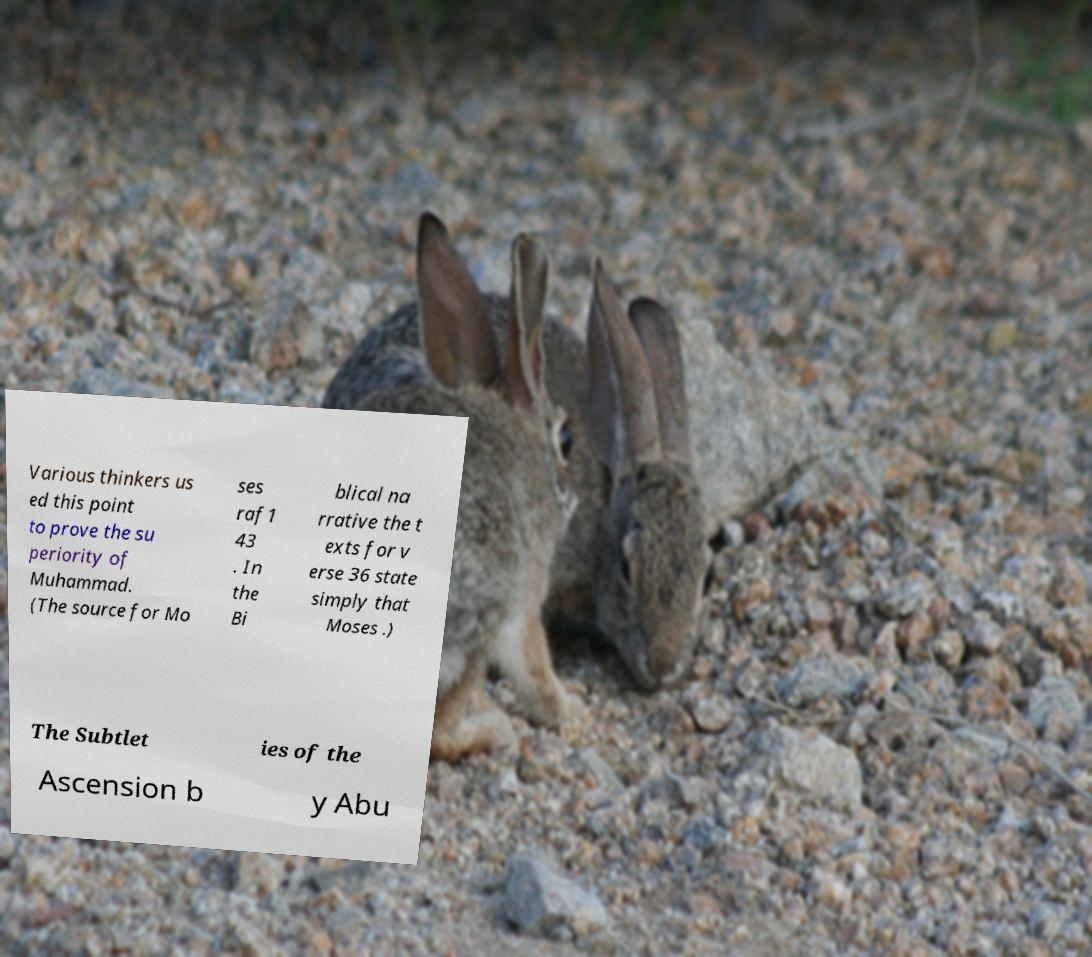Can you read and provide the text displayed in the image?This photo seems to have some interesting text. Can you extract and type it out for me? Various thinkers us ed this point to prove the su periority of Muhammad. (The source for Mo ses raf1 43 . In the Bi blical na rrative the t exts for v erse 36 state simply that Moses .) The Subtlet ies of the Ascension b y Abu 